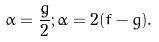Convert formula to latex. <formula><loc_0><loc_0><loc_500><loc_500>\alpha = \frac { \dot { g } } { 2 } ; \dot { \alpha } = 2 ( f - g ) .</formula> 